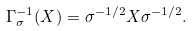<formula> <loc_0><loc_0><loc_500><loc_500>\Gamma _ { \sigma } ^ { - 1 } ( X ) = \sigma ^ { - 1 / 2 } X \sigma ^ { - 1 / 2 } .</formula> 